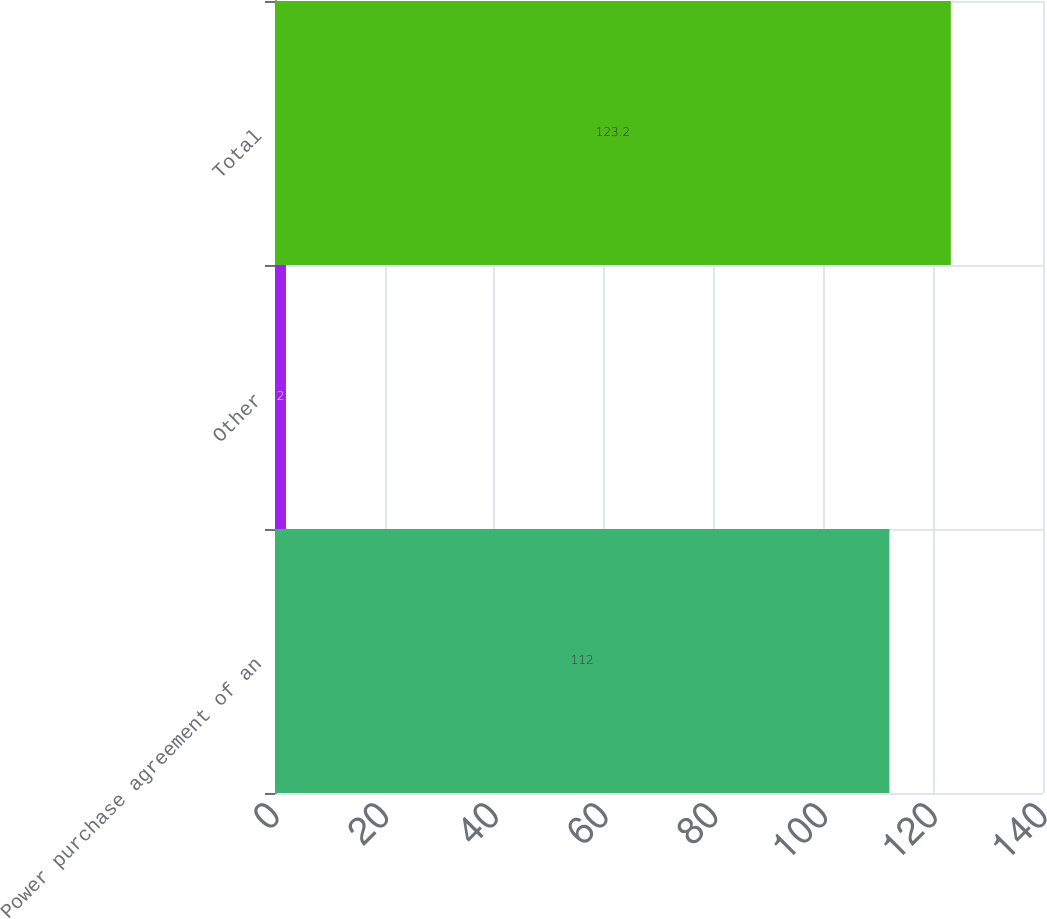Convert chart to OTSL. <chart><loc_0><loc_0><loc_500><loc_500><bar_chart><fcel>Power purchase agreement of an<fcel>Other<fcel>Total<nl><fcel>112<fcel>2<fcel>123.2<nl></chart> 